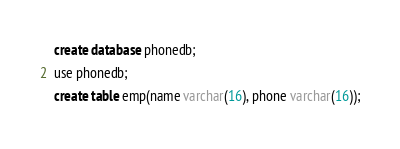Convert code to text. <code><loc_0><loc_0><loc_500><loc_500><_SQL_>create database phonedb;
use phonedb;
create table emp(name varchar(16), phone varchar(16));
</code> 